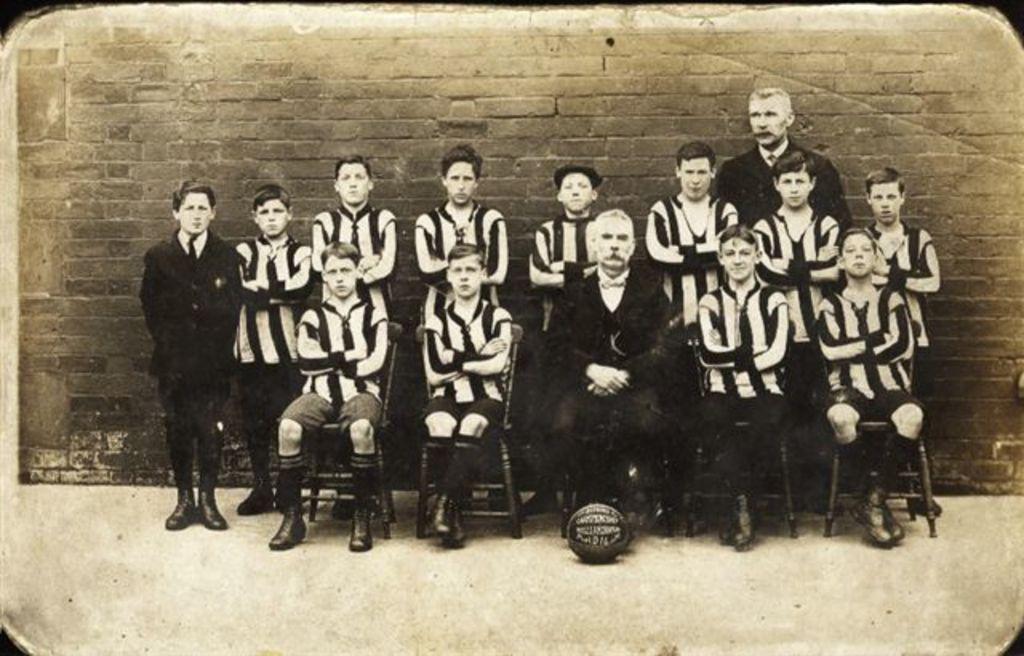Could you give a brief overview of what you see in this image? This is a black and white image. In this image we can see people sitting on chairs. Behind them there are people standing. In the background of the image there is wall. 